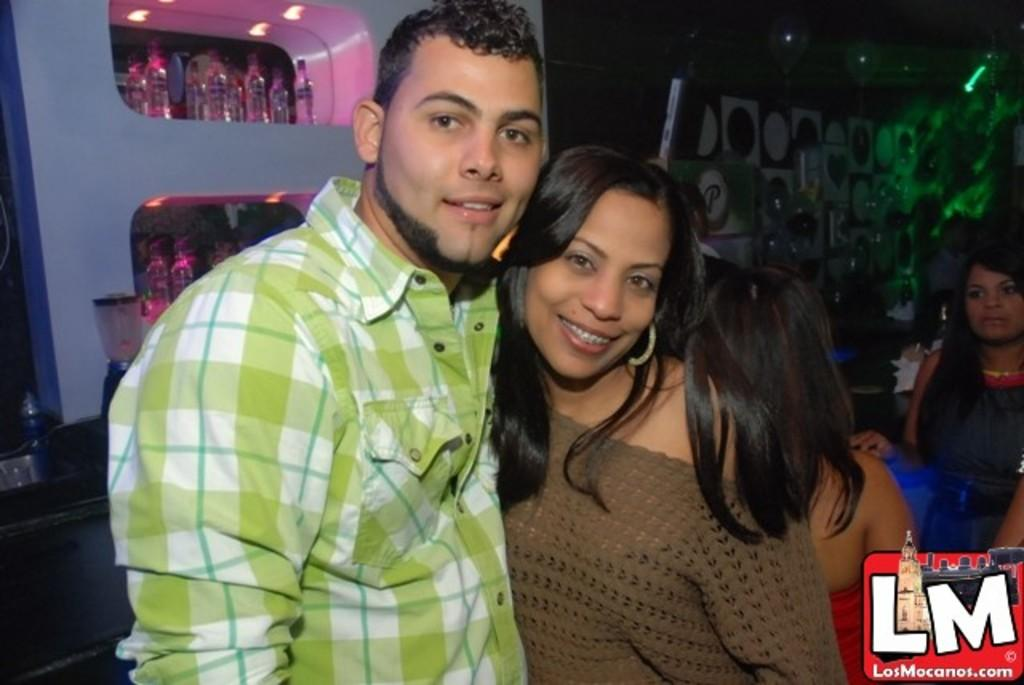Who or what can be seen in the image? There are people in the image. What objects are placed on a shelf in the image? There are bottles placed on a shelf in the image. What can be used for illumination in the image? There are lights visible in the image. What surface is present in the image for writing or displaying information? There is a board in the image. Where is the table located in the image? There is a table on the left side of the image. What type of vein is visible in the image? There is no vein visible in the image. What news is being discussed by the people in the image? The image does not provide any information about news being discussed by the people. 